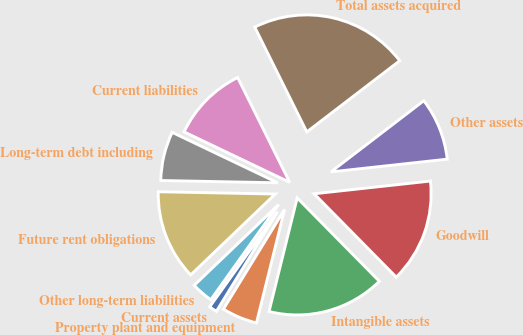Convert chart. <chart><loc_0><loc_0><loc_500><loc_500><pie_chart><fcel>Current assets<fcel>Property plant and equipment<fcel>Intangible assets<fcel>Goodwill<fcel>Other assets<fcel>Total assets acquired<fcel>Current liabilities<fcel>Long-term debt including<fcel>Future rent obligations<fcel>Other long-term liabilities<nl><fcel>1.1%<fcel>4.89%<fcel>16.25%<fcel>14.35%<fcel>8.67%<fcel>21.93%<fcel>10.57%<fcel>6.78%<fcel>12.46%<fcel>2.99%<nl></chart> 